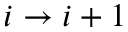<formula> <loc_0><loc_0><loc_500><loc_500>i \rightarrow i + 1</formula> 